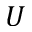<formula> <loc_0><loc_0><loc_500><loc_500>U</formula> 